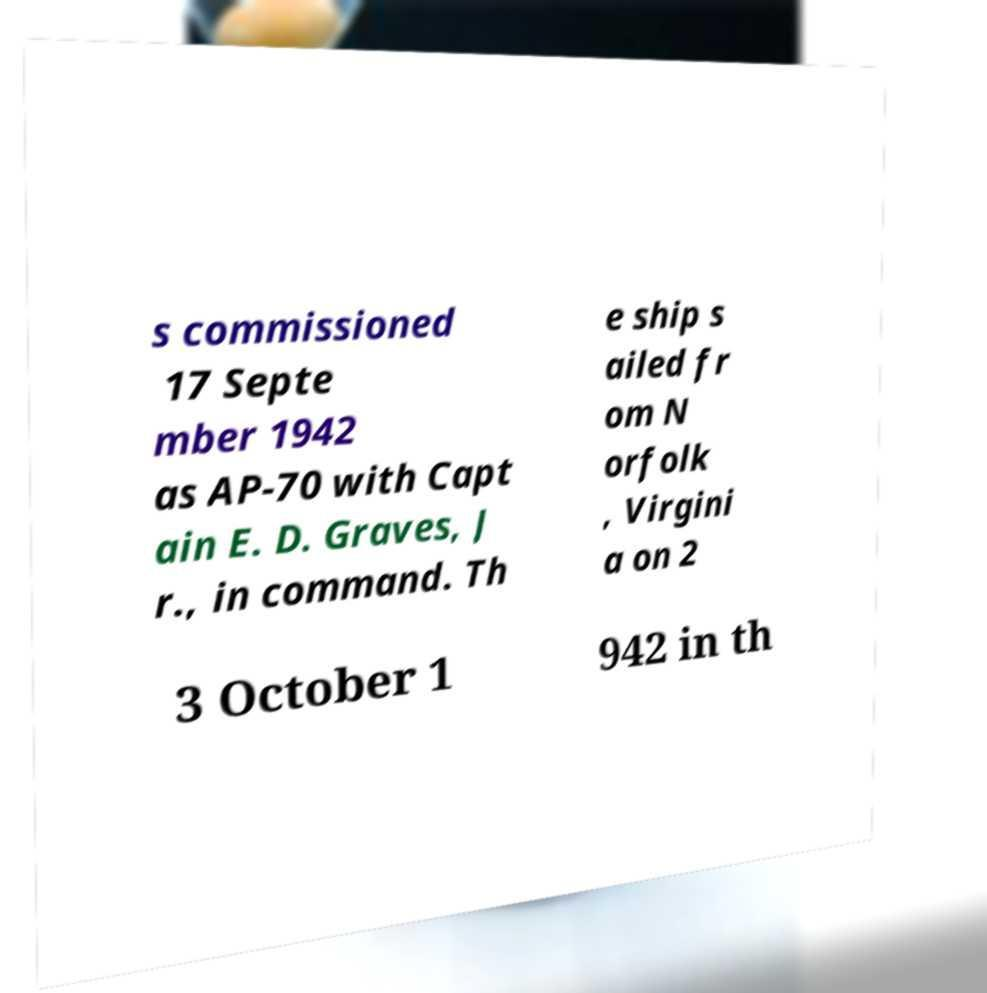There's text embedded in this image that I need extracted. Can you transcribe it verbatim? s commissioned 17 Septe mber 1942 as AP-70 with Capt ain E. D. Graves, J r., in command. Th e ship s ailed fr om N orfolk , Virgini a on 2 3 October 1 942 in th 